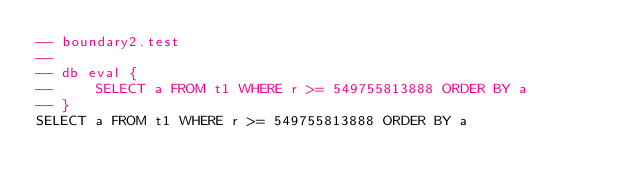Convert code to text. <code><loc_0><loc_0><loc_500><loc_500><_SQL_>-- boundary2.test
-- 
-- db eval {
--     SELECT a FROM t1 WHERE r >= 549755813888 ORDER BY a
-- }
SELECT a FROM t1 WHERE r >= 549755813888 ORDER BY a</code> 